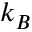<formula> <loc_0><loc_0><loc_500><loc_500>k _ { B }</formula> 